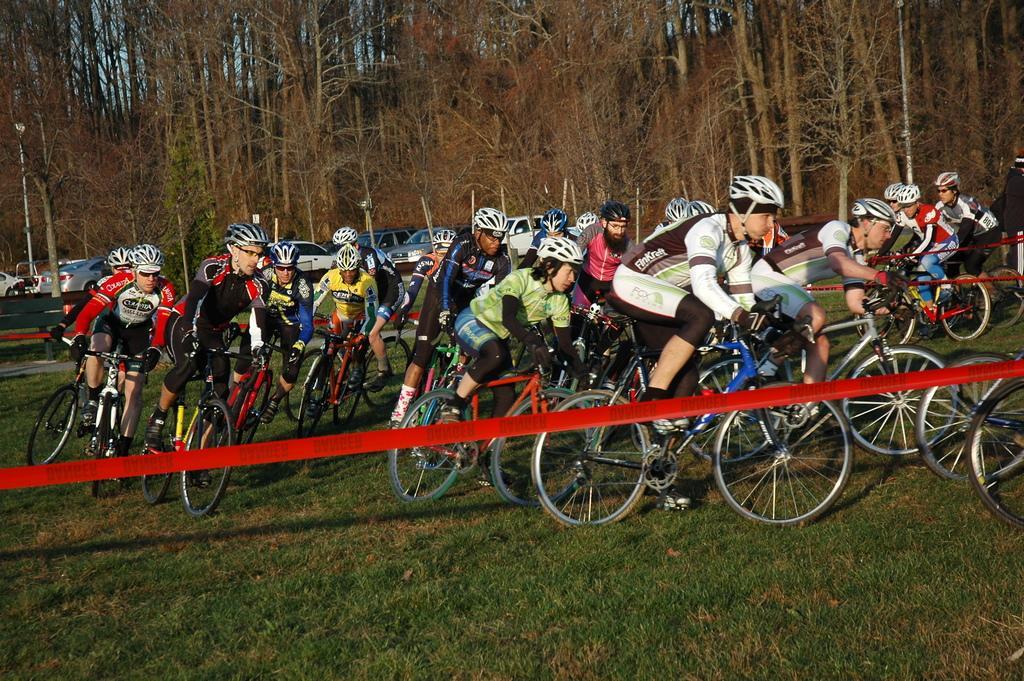Can you describe this image briefly? In the image we can see there are people sitting on the bicycle and they are wearing helmet. There is ground covered with grass and there are cars parked on the road. Behind there are trees. 